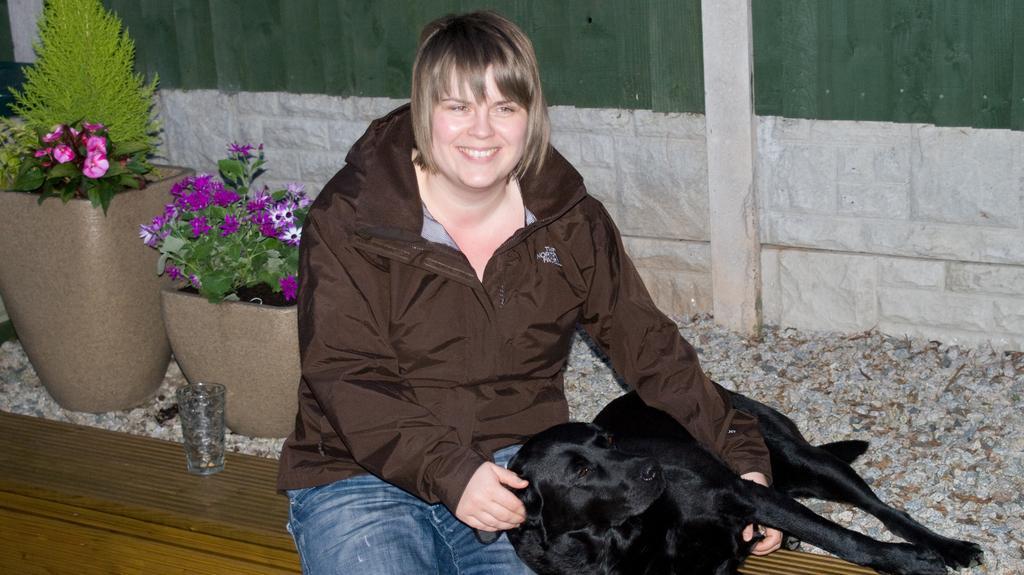In one or two sentences, can you explain what this image depicts? In the middle a woman is sitting and holding a dog beside her. On the left there is a glass and houseplants. 